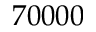<formula> <loc_0><loc_0><loc_500><loc_500>7 0 0 0 0</formula> 